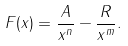Convert formula to latex. <formula><loc_0><loc_0><loc_500><loc_500>F ( x ) = \frac { A } { x ^ { n } } - \frac { R } { x ^ { m } } .</formula> 